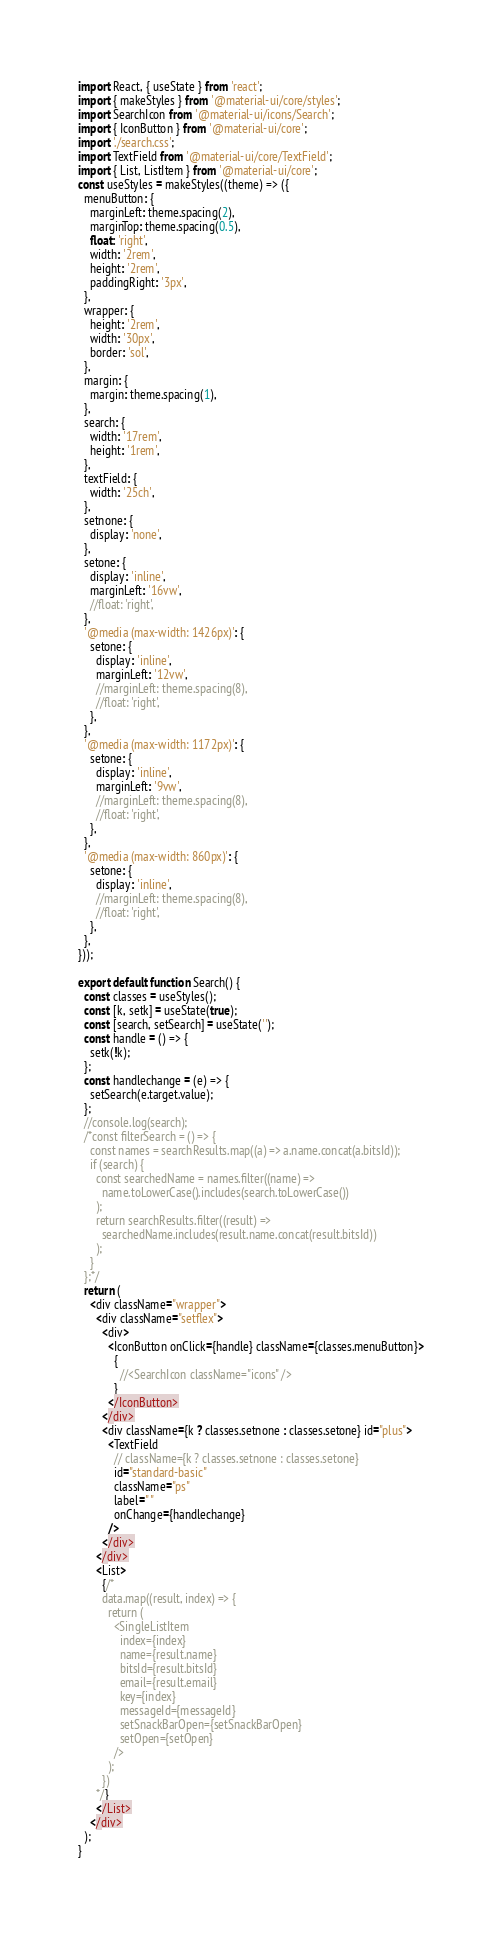<code> <loc_0><loc_0><loc_500><loc_500><_JavaScript_>import React, { useState } from 'react';
import { makeStyles } from '@material-ui/core/styles';
import SearchIcon from '@material-ui/icons/Search';
import { IconButton } from '@material-ui/core';
import './search.css';
import TextField from '@material-ui/core/TextField';
import { List, ListItem } from '@material-ui/core';
const useStyles = makeStyles((theme) => ({
  menuButton: {
    marginLeft: theme.spacing(2),
    marginTop: theme.spacing(0.5),
    float: 'right',
    width: '2rem',
    height: '2rem',
    paddingRight: '3px',
  },
  wrapper: {
    height: '2rem',
    width: '30px',
    border: 'sol',
  },
  margin: {
    margin: theme.spacing(1),
  },
  search: {
    width: '17rem',
    height: '1rem',
  },
  textField: {
    width: '25ch',
  },
  setnone: {
    display: 'none',
  },
  setone: {
    display: 'inline',
    marginLeft: '16vw',
    //float: 'right',
  },
  '@media (max-width: 1426px)': {
    setone: {
      display: 'inline',
      marginLeft: '12vw',
      //marginLeft: theme.spacing(8),
      //float: 'right',
    },
  },
  '@media (max-width: 1172px)': {
    setone: {
      display: 'inline',
      marginLeft: '9vw',
      //marginLeft: theme.spacing(8),
      //float: 'right',
    },
  },
  '@media (max-width: 860px)': {
    setone: {
      display: 'inline',
      //marginLeft: theme.spacing(8),
      //float: 'right',
    },
  },
}));

export default function Search() {
  const classes = useStyles();
  const [k, setk] = useState(true);
  const [search, setSearch] = useState('');
  const handle = () => {
    setk(!k);
  };
  const handlechange = (e) => {
    setSearch(e.target.value);
  };
  //console.log(search);
  /*const filterSearch = () => {
    const names = searchResults.map((a) => a.name.concat(a.bitsId));
    if (search) {
      const searchedName = names.filter((name) =>
        name.toLowerCase().includes(search.toLowerCase())
      );
      return searchResults.filter((result) =>
        searchedName.includes(result.name.concat(result.bitsId))
      );
    }
  };*/
  return (
    <div className="wrapper">
      <div className="setflex">
        <div>
          <IconButton onClick={handle} className={classes.menuButton}>
            {
              //<SearchIcon className="icons" />
            }
          </IconButton>
        </div>
        <div className={k ? classes.setnone : classes.setone} id="plus">
          <TextField
            // className={k ? classes.setnone : classes.setone}
            id="standard-basic"
            className="ps"
            label=" "
            onChange={handlechange}
          />
        </div>
      </div>
      <List>
        {/*
        data.map((result, index) => {
          return (
            <SingleListItem
              index={index}
              name={result.name}
              bitsId={result.bitsId}
              email={result.email}
              key={index}
              messageId={messageId}
              setSnackBarOpen={setSnackBarOpen}
              setOpen={setOpen}
            />
          );
        })
      */}
      </List>
    </div>
  );
}
</code> 